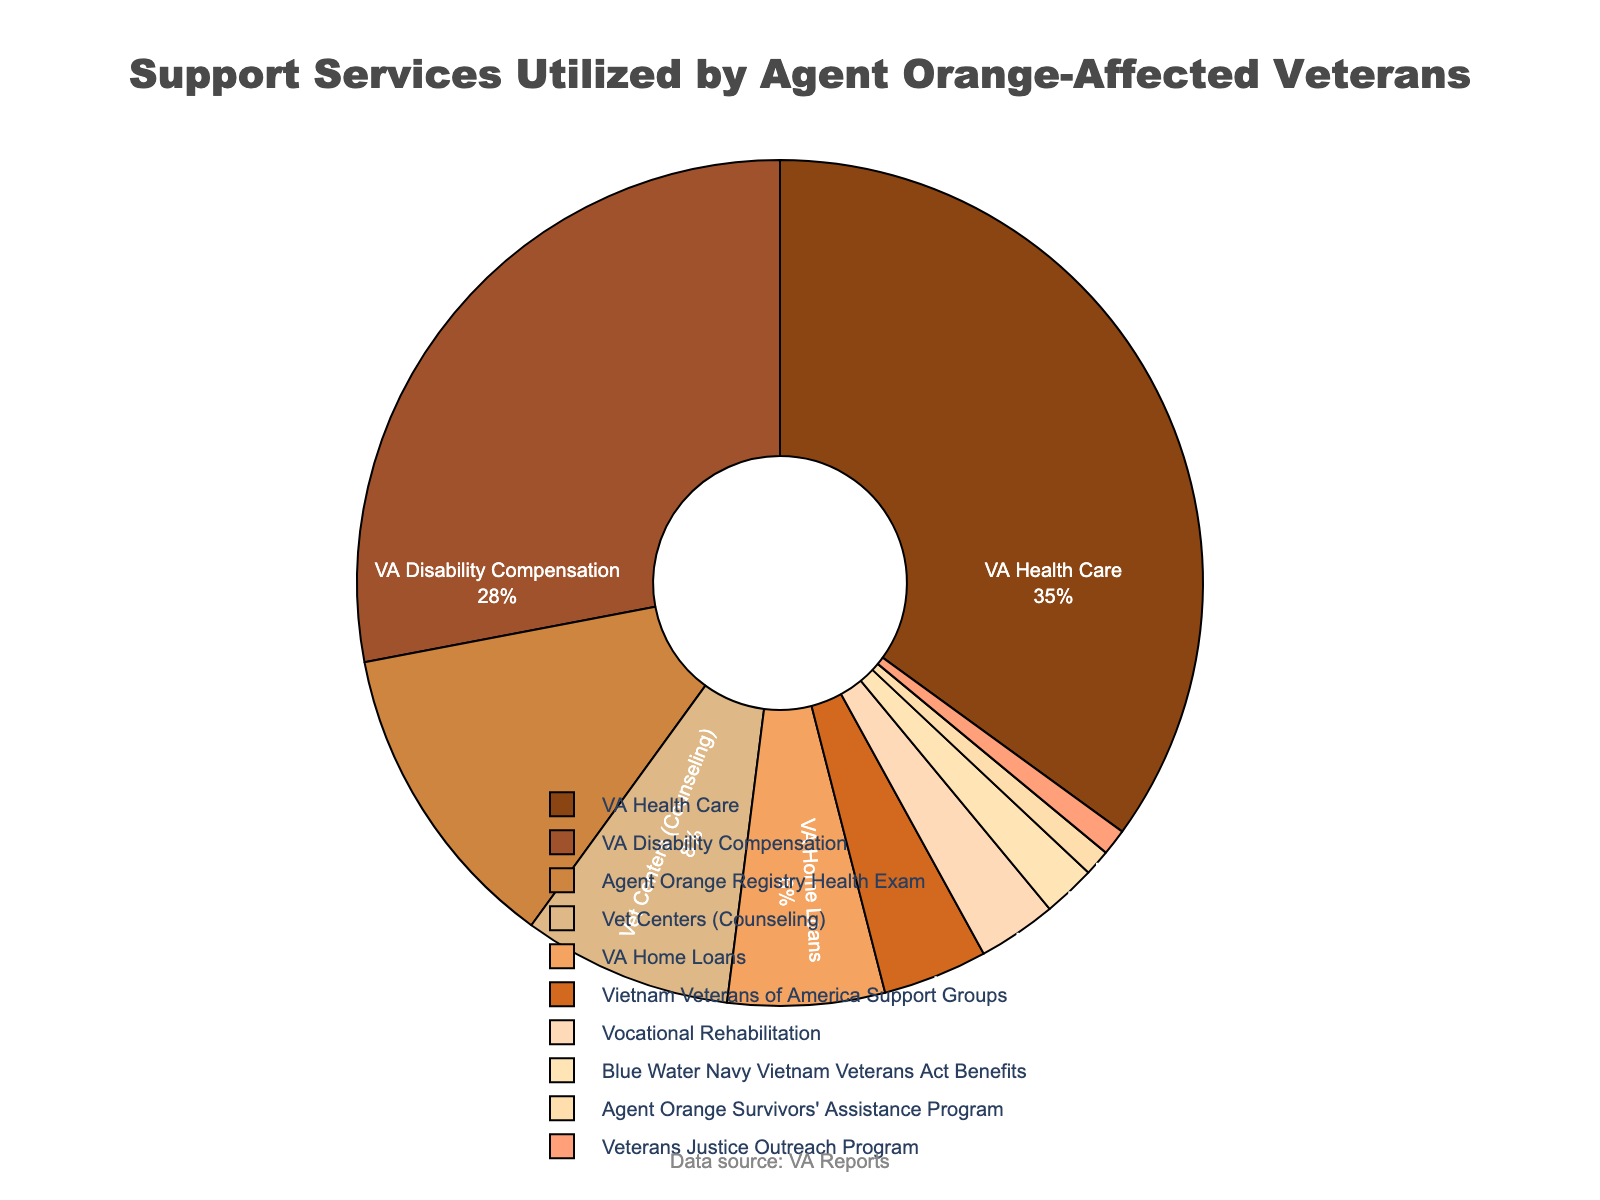What percentage of veterans utilized VA Health Care compared to those who utilized VA Disability Compensation? The pie chart indicates that 35% of veterans utilized VA Health Care and 28% utilized VA Disability Compensation. By subtracting 28% from 35%, we find the difference.
Answer: 7% What services fall below the 10% utilization rate threshold? We need to look at the sections of the pie chart that indicate less than 10%. These are Vet Centers (Counseling), VA Home Loans, Vietnam Veterans of America Support Groups, Vocational Rehabilitation, Blue Water Navy Vietnam Veterans Act Benefits, Agent Orange Survivors' Assistance Program, and Veterans Justice Outreach Program.
Answer: Seven services Which service is used by the smallest percentage of veterans and what is that percentage? The pie chart shows that the smallest segment corresponds to the Veterans Justice Outreach Program and the Agent Orange Survivors' Assistance Program, each with a percentage value.
Answer: 1% What services combined account for over 60% of utilization? Adding up the highest percentages from the pie chart: VA Health Care (35%) + VA Disability Compensation (28%), we get 35% + 28% = 63%, which is over 60%.
Answer: VA Health Care and VA Disability Compensation What is the visual representation of the service with the largest utilization rate, and what is its percentage? The section of the pie chart represented by the largest slice with the associated percentage label indicates this. The largest segment corresponds to VA Health Care.
Answer: 35% Compare the utilization rate of VA Home Loans to the Vietnam Veterans of America Support Groups. Which is higher and by how much? According to the pie chart, VA Home Loans account for 6% and Vietnam Veterans of America Support Groups account for 4%. Subtracting these values gives 6% - 4% = 2%.
Answer: VA Home Loans by 2% What fraction of the pie chart is represented by Vet Centers (Counseling) and VA Home Loans together? By adding their percentages: Vet Centers (Counseling) 8% + VA Home Loans 6%, we get 8% + 6% = 14%.
Answer: 14% Which services, when combined, make up exactly 15% of the pie chart? By looking at the segments, we can find suitable combinations that add up to 15%. Two such combinations are VA Home Loans (6%) + Vietnam Veterans of America Support Groups (4%) + Agent Orange Registry Health Exam (12%) – 6% ≠ 15%, but Vietnam Veterans of America Support Groups (4%) + Vocational Rehabilitation (3%) + Blue Water Navy Vietnam Veterans Act Benefits (2%) + Agent Orange Survivors' Assistance Program (1%) + Veterans Justice Outreach Program (1%) totals 4% + 3% + 2% + 1% + 1% = 11%. No group makes exactly 15% in the given data.
Answer: No exact match What services are between 5% and 10% utilization? Check the segments of the pie chart that fall within this range, which corresponds to VA Home Loans (6%).
Answer: VA Home Loans How do vocational rehabilitation services and VA health care compare in terms of percentage utilization? According to the chart, vocational rehabilitation services have a utilization rate of 3%, while VA Health Care has a rate of 35%. The difference is 35% - 3% = 32%.
Answer: VA Health Care is 32% higher 